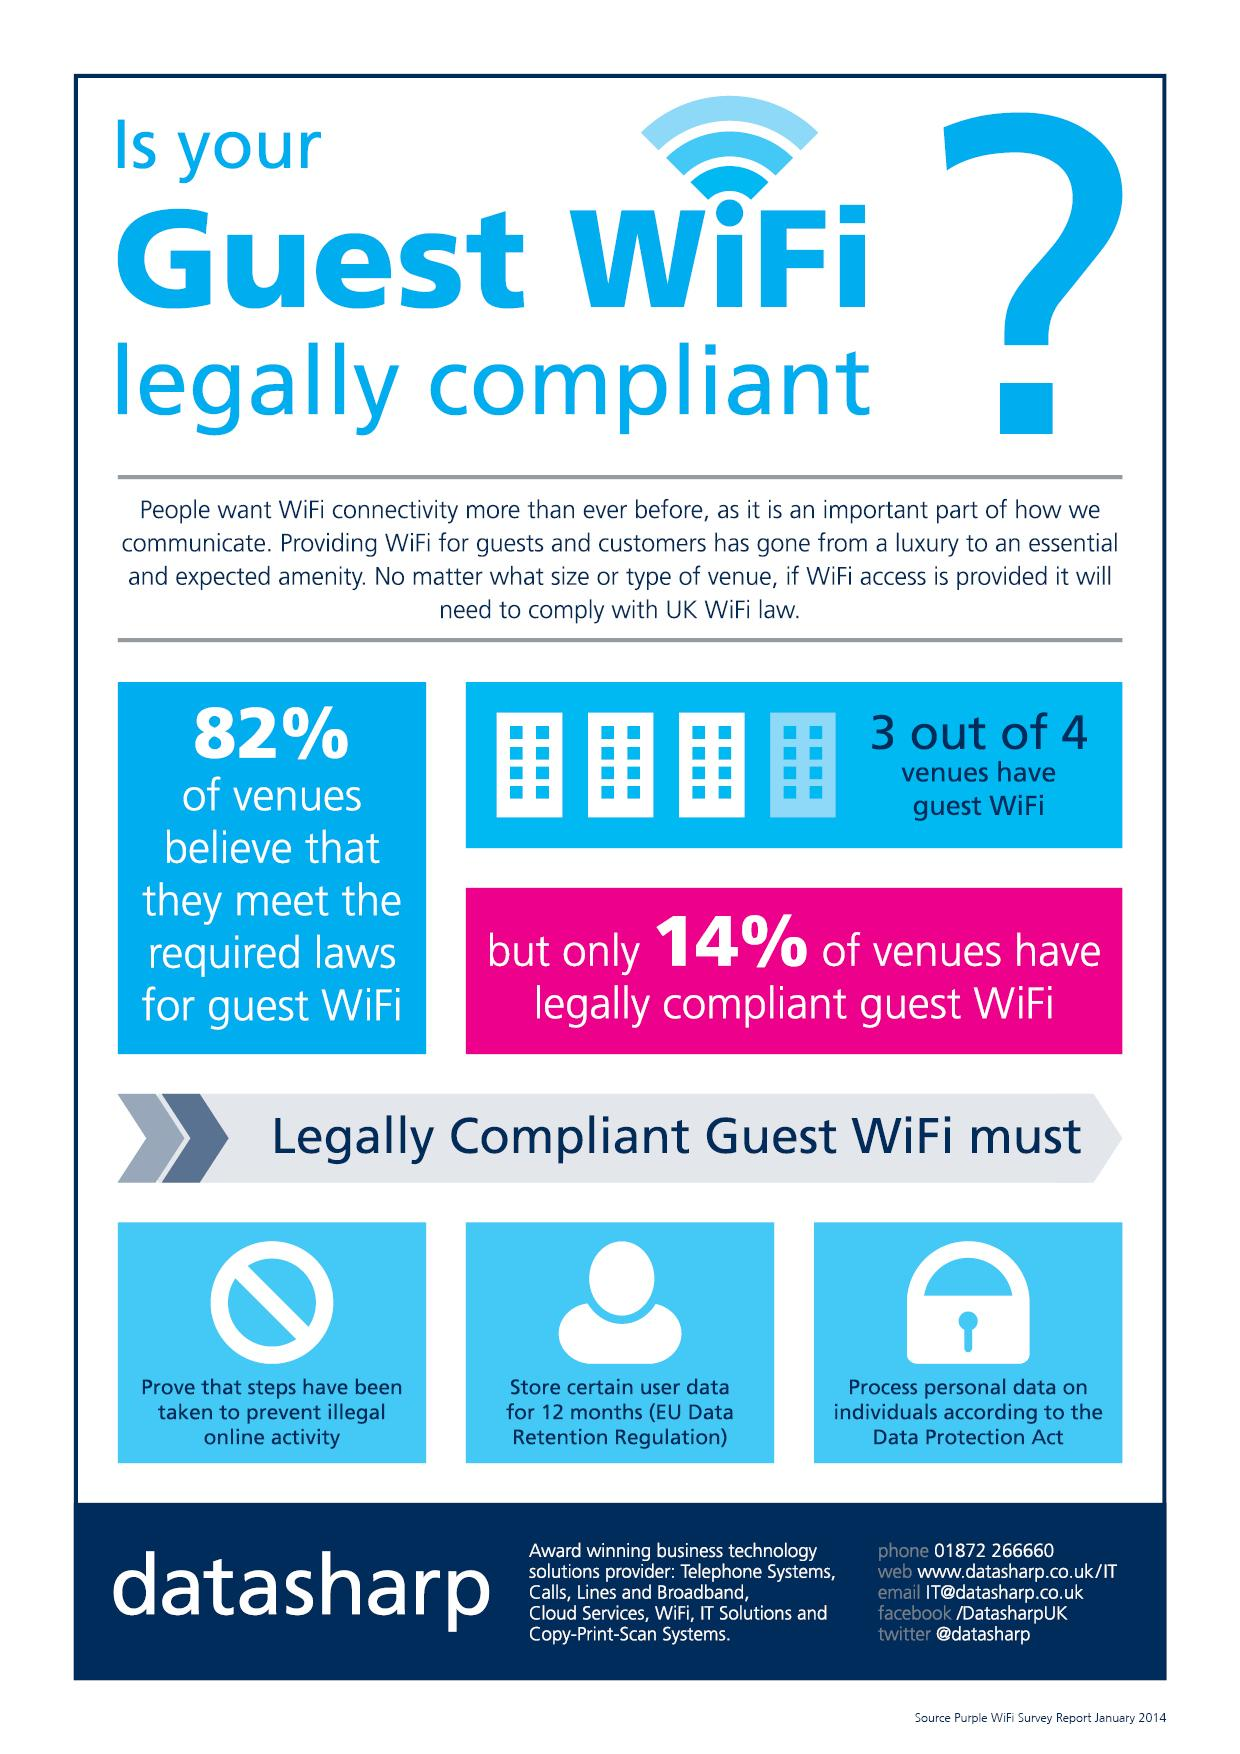Give some essential details in this illustration. The color of the question mark symbol is typically blue, but it can also be white or black. The number of icons of lock in this infographic is one. According to a survey, a significant majority of venues, approximately 75%, provide guest Wi-Fi. A substantial proportion, approximately 25%, of venues lack guest Wi-Fi. To be considered legally compliant for guest Wi-Fi, the process of personal data must be handled in accordance with the Data Protection Act. 